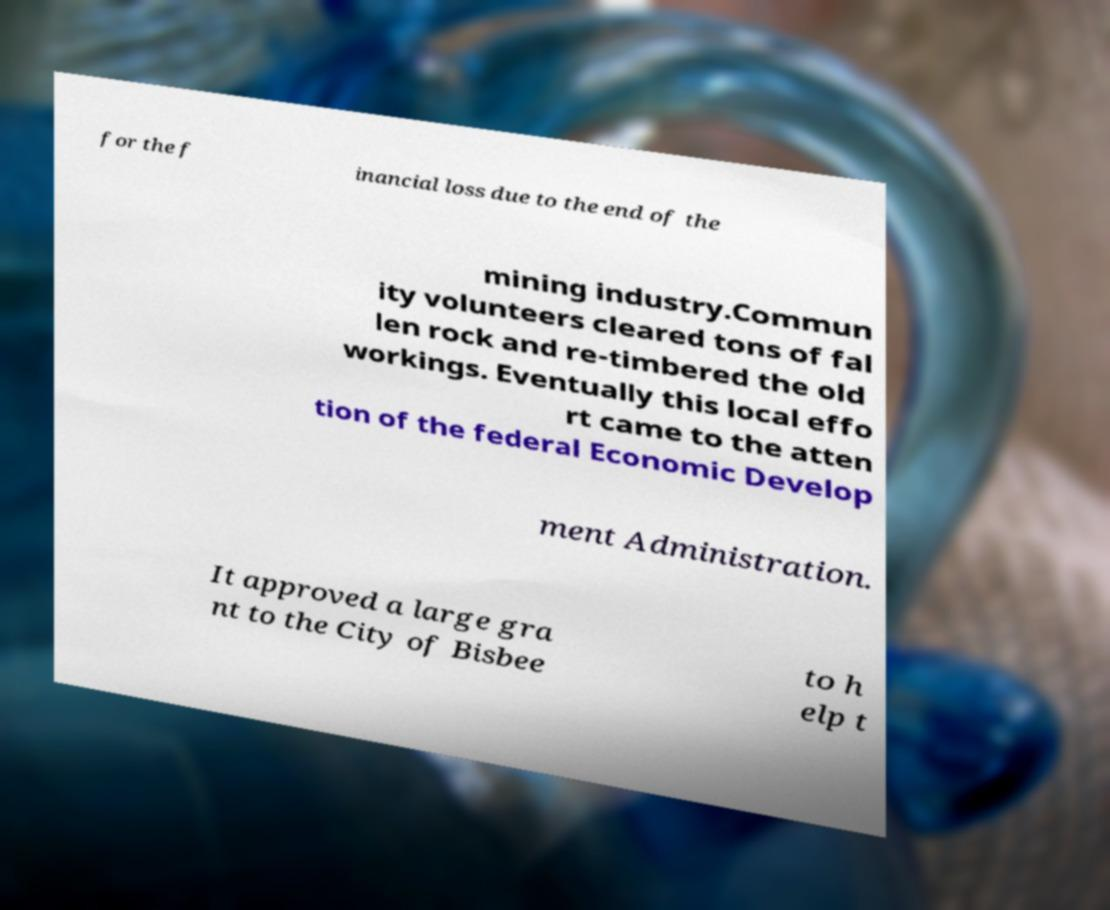Could you assist in decoding the text presented in this image and type it out clearly? for the f inancial loss due to the end of the mining industry.Commun ity volunteers cleared tons of fal len rock and re-timbered the old workings. Eventually this local effo rt came to the atten tion of the federal Economic Develop ment Administration. It approved a large gra nt to the City of Bisbee to h elp t 